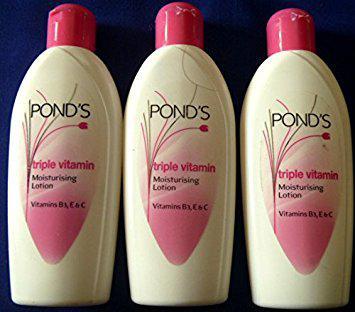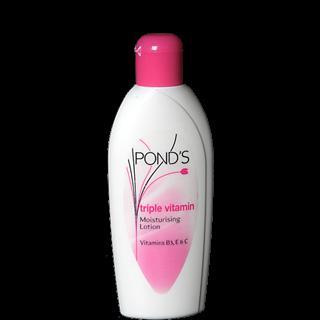The first image is the image on the left, the second image is the image on the right. Given the left and right images, does the statement "One image has a single tube of beauty cream standing on end." hold true? Answer yes or no. No. The first image is the image on the left, the second image is the image on the right. For the images displayed, is the sentence "There are not more than two different products and they are all made by Ponds." factually correct? Answer yes or no. Yes. 